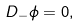<formula> <loc_0><loc_0><loc_500><loc_500>D _ { - } { \phi } = 0 ,</formula> 